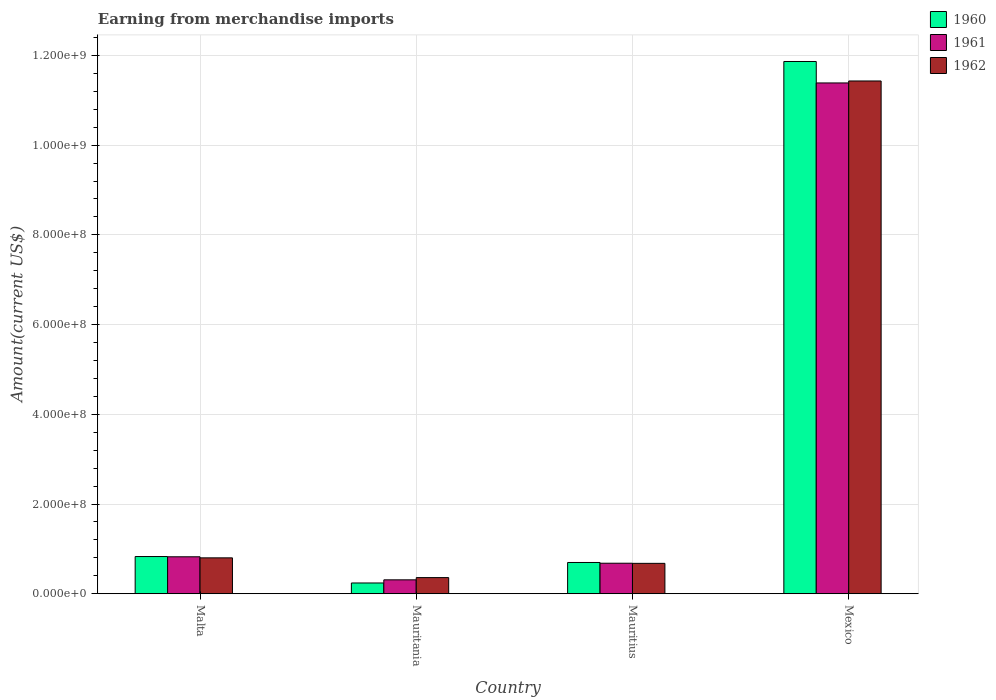How many different coloured bars are there?
Your answer should be very brief. 3. Are the number of bars per tick equal to the number of legend labels?
Your answer should be compact. Yes. Are the number of bars on each tick of the X-axis equal?
Provide a short and direct response. Yes. How many bars are there on the 2nd tick from the right?
Keep it short and to the point. 3. What is the label of the 2nd group of bars from the left?
Ensure brevity in your answer.  Mauritania. What is the amount earned from merchandise imports in 1961 in Mauritania?
Offer a terse response. 3.10e+07. Across all countries, what is the maximum amount earned from merchandise imports in 1961?
Give a very brief answer. 1.14e+09. Across all countries, what is the minimum amount earned from merchandise imports in 1962?
Your answer should be very brief. 3.60e+07. In which country was the amount earned from merchandise imports in 1962 maximum?
Offer a terse response. Mexico. In which country was the amount earned from merchandise imports in 1961 minimum?
Your answer should be very brief. Mauritania. What is the total amount earned from merchandise imports in 1961 in the graph?
Ensure brevity in your answer.  1.32e+09. What is the difference between the amount earned from merchandise imports in 1960 in Malta and that in Mauritius?
Keep it short and to the point. 1.32e+07. What is the difference between the amount earned from merchandise imports in 1960 in Malta and the amount earned from merchandise imports in 1961 in Mauritania?
Keep it short and to the point. 5.19e+07. What is the average amount earned from merchandise imports in 1960 per country?
Offer a very short reply. 3.41e+08. In how many countries, is the amount earned from merchandise imports in 1961 greater than 200000000 US$?
Your response must be concise. 1. What is the ratio of the amount earned from merchandise imports in 1960 in Malta to that in Mexico?
Offer a terse response. 0.07. Is the amount earned from merchandise imports in 1960 in Mauritius less than that in Mexico?
Your response must be concise. Yes. What is the difference between the highest and the second highest amount earned from merchandise imports in 1960?
Offer a very short reply. 1.10e+09. What is the difference between the highest and the lowest amount earned from merchandise imports in 1960?
Give a very brief answer. 1.16e+09. In how many countries, is the amount earned from merchandise imports in 1962 greater than the average amount earned from merchandise imports in 1962 taken over all countries?
Ensure brevity in your answer.  1. Is the sum of the amount earned from merchandise imports in 1960 in Malta and Mauritania greater than the maximum amount earned from merchandise imports in 1962 across all countries?
Your response must be concise. No. What does the 1st bar from the right in Malta represents?
Ensure brevity in your answer.  1962. How many bars are there?
Offer a very short reply. 12. Are all the bars in the graph horizontal?
Keep it short and to the point. No. What is the difference between two consecutive major ticks on the Y-axis?
Your answer should be compact. 2.00e+08. Are the values on the major ticks of Y-axis written in scientific E-notation?
Make the answer very short. Yes. Does the graph contain grids?
Offer a very short reply. Yes. What is the title of the graph?
Keep it short and to the point. Earning from merchandise imports. Does "2006" appear as one of the legend labels in the graph?
Provide a succinct answer. No. What is the label or title of the X-axis?
Offer a very short reply. Country. What is the label or title of the Y-axis?
Your answer should be very brief. Amount(current US$). What is the Amount(current US$) in 1960 in Malta?
Your answer should be compact. 8.29e+07. What is the Amount(current US$) of 1961 in Malta?
Provide a short and direct response. 8.24e+07. What is the Amount(current US$) in 1962 in Malta?
Provide a succinct answer. 8.00e+07. What is the Amount(current US$) in 1960 in Mauritania?
Your response must be concise. 2.40e+07. What is the Amount(current US$) in 1961 in Mauritania?
Provide a succinct answer. 3.10e+07. What is the Amount(current US$) in 1962 in Mauritania?
Provide a short and direct response. 3.60e+07. What is the Amount(current US$) in 1960 in Mauritius?
Your response must be concise. 6.97e+07. What is the Amount(current US$) in 1961 in Mauritius?
Provide a succinct answer. 6.80e+07. What is the Amount(current US$) of 1962 in Mauritius?
Provide a succinct answer. 6.78e+07. What is the Amount(current US$) of 1960 in Mexico?
Offer a terse response. 1.19e+09. What is the Amount(current US$) in 1961 in Mexico?
Make the answer very short. 1.14e+09. What is the Amount(current US$) in 1962 in Mexico?
Your answer should be compact. 1.14e+09. Across all countries, what is the maximum Amount(current US$) of 1960?
Ensure brevity in your answer.  1.19e+09. Across all countries, what is the maximum Amount(current US$) of 1961?
Offer a very short reply. 1.14e+09. Across all countries, what is the maximum Amount(current US$) of 1962?
Keep it short and to the point. 1.14e+09. Across all countries, what is the minimum Amount(current US$) in 1960?
Keep it short and to the point. 2.40e+07. Across all countries, what is the minimum Amount(current US$) of 1961?
Keep it short and to the point. 3.10e+07. Across all countries, what is the minimum Amount(current US$) of 1962?
Give a very brief answer. 3.60e+07. What is the total Amount(current US$) of 1960 in the graph?
Your response must be concise. 1.36e+09. What is the total Amount(current US$) in 1961 in the graph?
Provide a short and direct response. 1.32e+09. What is the total Amount(current US$) in 1962 in the graph?
Your response must be concise. 1.33e+09. What is the difference between the Amount(current US$) in 1960 in Malta and that in Mauritania?
Make the answer very short. 5.89e+07. What is the difference between the Amount(current US$) of 1961 in Malta and that in Mauritania?
Your answer should be very brief. 5.14e+07. What is the difference between the Amount(current US$) of 1962 in Malta and that in Mauritania?
Make the answer very short. 4.40e+07. What is the difference between the Amount(current US$) in 1960 in Malta and that in Mauritius?
Your answer should be very brief. 1.32e+07. What is the difference between the Amount(current US$) in 1961 in Malta and that in Mauritius?
Your answer should be compact. 1.44e+07. What is the difference between the Amount(current US$) in 1962 in Malta and that in Mauritius?
Your response must be concise. 1.22e+07. What is the difference between the Amount(current US$) of 1960 in Malta and that in Mexico?
Your answer should be compact. -1.10e+09. What is the difference between the Amount(current US$) in 1961 in Malta and that in Mexico?
Offer a very short reply. -1.06e+09. What is the difference between the Amount(current US$) in 1962 in Malta and that in Mexico?
Make the answer very short. -1.06e+09. What is the difference between the Amount(current US$) of 1960 in Mauritania and that in Mauritius?
Keep it short and to the point. -4.57e+07. What is the difference between the Amount(current US$) of 1961 in Mauritania and that in Mauritius?
Your response must be concise. -3.70e+07. What is the difference between the Amount(current US$) in 1962 in Mauritania and that in Mauritius?
Make the answer very short. -3.18e+07. What is the difference between the Amount(current US$) in 1960 in Mauritania and that in Mexico?
Offer a very short reply. -1.16e+09. What is the difference between the Amount(current US$) in 1961 in Mauritania and that in Mexico?
Your answer should be very brief. -1.11e+09. What is the difference between the Amount(current US$) in 1962 in Mauritania and that in Mexico?
Ensure brevity in your answer.  -1.11e+09. What is the difference between the Amount(current US$) of 1960 in Mauritius and that in Mexico?
Keep it short and to the point. -1.12e+09. What is the difference between the Amount(current US$) in 1961 in Mauritius and that in Mexico?
Your answer should be compact. -1.07e+09. What is the difference between the Amount(current US$) in 1962 in Mauritius and that in Mexico?
Give a very brief answer. -1.08e+09. What is the difference between the Amount(current US$) in 1960 in Malta and the Amount(current US$) in 1961 in Mauritania?
Provide a short and direct response. 5.19e+07. What is the difference between the Amount(current US$) of 1960 in Malta and the Amount(current US$) of 1962 in Mauritania?
Your answer should be compact. 4.69e+07. What is the difference between the Amount(current US$) of 1961 in Malta and the Amount(current US$) of 1962 in Mauritania?
Provide a succinct answer. 4.64e+07. What is the difference between the Amount(current US$) of 1960 in Malta and the Amount(current US$) of 1961 in Mauritius?
Your answer should be compact. 1.49e+07. What is the difference between the Amount(current US$) of 1960 in Malta and the Amount(current US$) of 1962 in Mauritius?
Provide a short and direct response. 1.52e+07. What is the difference between the Amount(current US$) of 1961 in Malta and the Amount(current US$) of 1962 in Mauritius?
Keep it short and to the point. 1.46e+07. What is the difference between the Amount(current US$) of 1960 in Malta and the Amount(current US$) of 1961 in Mexico?
Your response must be concise. -1.06e+09. What is the difference between the Amount(current US$) of 1960 in Malta and the Amount(current US$) of 1962 in Mexico?
Give a very brief answer. -1.06e+09. What is the difference between the Amount(current US$) of 1961 in Malta and the Amount(current US$) of 1962 in Mexico?
Make the answer very short. -1.06e+09. What is the difference between the Amount(current US$) in 1960 in Mauritania and the Amount(current US$) in 1961 in Mauritius?
Offer a terse response. -4.40e+07. What is the difference between the Amount(current US$) in 1960 in Mauritania and the Amount(current US$) in 1962 in Mauritius?
Provide a succinct answer. -4.38e+07. What is the difference between the Amount(current US$) of 1961 in Mauritania and the Amount(current US$) of 1962 in Mauritius?
Make the answer very short. -3.68e+07. What is the difference between the Amount(current US$) in 1960 in Mauritania and the Amount(current US$) in 1961 in Mexico?
Your answer should be very brief. -1.11e+09. What is the difference between the Amount(current US$) of 1960 in Mauritania and the Amount(current US$) of 1962 in Mexico?
Keep it short and to the point. -1.12e+09. What is the difference between the Amount(current US$) in 1961 in Mauritania and the Amount(current US$) in 1962 in Mexico?
Your answer should be compact. -1.11e+09. What is the difference between the Amount(current US$) in 1960 in Mauritius and the Amount(current US$) in 1961 in Mexico?
Your response must be concise. -1.07e+09. What is the difference between the Amount(current US$) in 1960 in Mauritius and the Amount(current US$) in 1962 in Mexico?
Your answer should be compact. -1.07e+09. What is the difference between the Amount(current US$) of 1961 in Mauritius and the Amount(current US$) of 1962 in Mexico?
Your response must be concise. -1.07e+09. What is the average Amount(current US$) in 1960 per country?
Your answer should be compact. 3.41e+08. What is the average Amount(current US$) of 1961 per country?
Make the answer very short. 3.30e+08. What is the average Amount(current US$) of 1962 per country?
Make the answer very short. 3.32e+08. What is the difference between the Amount(current US$) of 1960 and Amount(current US$) of 1961 in Malta?
Keep it short and to the point. 5.29e+05. What is the difference between the Amount(current US$) in 1960 and Amount(current US$) in 1962 in Malta?
Offer a very short reply. 2.91e+06. What is the difference between the Amount(current US$) in 1961 and Amount(current US$) in 1962 in Malta?
Your answer should be very brief. 2.38e+06. What is the difference between the Amount(current US$) in 1960 and Amount(current US$) in 1961 in Mauritania?
Provide a short and direct response. -7.00e+06. What is the difference between the Amount(current US$) in 1960 and Amount(current US$) in 1962 in Mauritania?
Offer a very short reply. -1.20e+07. What is the difference between the Amount(current US$) in 1961 and Amount(current US$) in 1962 in Mauritania?
Offer a terse response. -5.00e+06. What is the difference between the Amount(current US$) in 1960 and Amount(current US$) in 1961 in Mauritius?
Make the answer very short. 1.66e+06. What is the difference between the Amount(current US$) in 1960 and Amount(current US$) in 1962 in Mauritius?
Offer a terse response. 1.93e+06. What is the difference between the Amount(current US$) of 1961 and Amount(current US$) of 1962 in Mauritius?
Your answer should be very brief. 2.73e+05. What is the difference between the Amount(current US$) of 1960 and Amount(current US$) of 1961 in Mexico?
Your response must be concise. 4.78e+07. What is the difference between the Amount(current US$) of 1960 and Amount(current US$) of 1962 in Mexico?
Your answer should be very brief. 4.34e+07. What is the difference between the Amount(current US$) of 1961 and Amount(current US$) of 1962 in Mexico?
Your answer should be compact. -4.40e+06. What is the ratio of the Amount(current US$) of 1960 in Malta to that in Mauritania?
Provide a short and direct response. 3.46. What is the ratio of the Amount(current US$) of 1961 in Malta to that in Mauritania?
Provide a succinct answer. 2.66. What is the ratio of the Amount(current US$) in 1962 in Malta to that in Mauritania?
Keep it short and to the point. 2.22. What is the ratio of the Amount(current US$) in 1960 in Malta to that in Mauritius?
Ensure brevity in your answer.  1.19. What is the ratio of the Amount(current US$) in 1961 in Malta to that in Mauritius?
Offer a very short reply. 1.21. What is the ratio of the Amount(current US$) of 1962 in Malta to that in Mauritius?
Offer a very short reply. 1.18. What is the ratio of the Amount(current US$) of 1960 in Malta to that in Mexico?
Make the answer very short. 0.07. What is the ratio of the Amount(current US$) in 1961 in Malta to that in Mexico?
Give a very brief answer. 0.07. What is the ratio of the Amount(current US$) of 1962 in Malta to that in Mexico?
Give a very brief answer. 0.07. What is the ratio of the Amount(current US$) of 1960 in Mauritania to that in Mauritius?
Keep it short and to the point. 0.34. What is the ratio of the Amount(current US$) of 1961 in Mauritania to that in Mauritius?
Provide a succinct answer. 0.46. What is the ratio of the Amount(current US$) in 1962 in Mauritania to that in Mauritius?
Make the answer very short. 0.53. What is the ratio of the Amount(current US$) in 1960 in Mauritania to that in Mexico?
Offer a very short reply. 0.02. What is the ratio of the Amount(current US$) in 1961 in Mauritania to that in Mexico?
Offer a terse response. 0.03. What is the ratio of the Amount(current US$) of 1962 in Mauritania to that in Mexico?
Make the answer very short. 0.03. What is the ratio of the Amount(current US$) of 1960 in Mauritius to that in Mexico?
Provide a short and direct response. 0.06. What is the ratio of the Amount(current US$) in 1961 in Mauritius to that in Mexico?
Give a very brief answer. 0.06. What is the ratio of the Amount(current US$) of 1962 in Mauritius to that in Mexico?
Provide a succinct answer. 0.06. What is the difference between the highest and the second highest Amount(current US$) in 1960?
Offer a very short reply. 1.10e+09. What is the difference between the highest and the second highest Amount(current US$) of 1961?
Keep it short and to the point. 1.06e+09. What is the difference between the highest and the second highest Amount(current US$) of 1962?
Your response must be concise. 1.06e+09. What is the difference between the highest and the lowest Amount(current US$) of 1960?
Provide a short and direct response. 1.16e+09. What is the difference between the highest and the lowest Amount(current US$) in 1961?
Ensure brevity in your answer.  1.11e+09. What is the difference between the highest and the lowest Amount(current US$) of 1962?
Provide a short and direct response. 1.11e+09. 